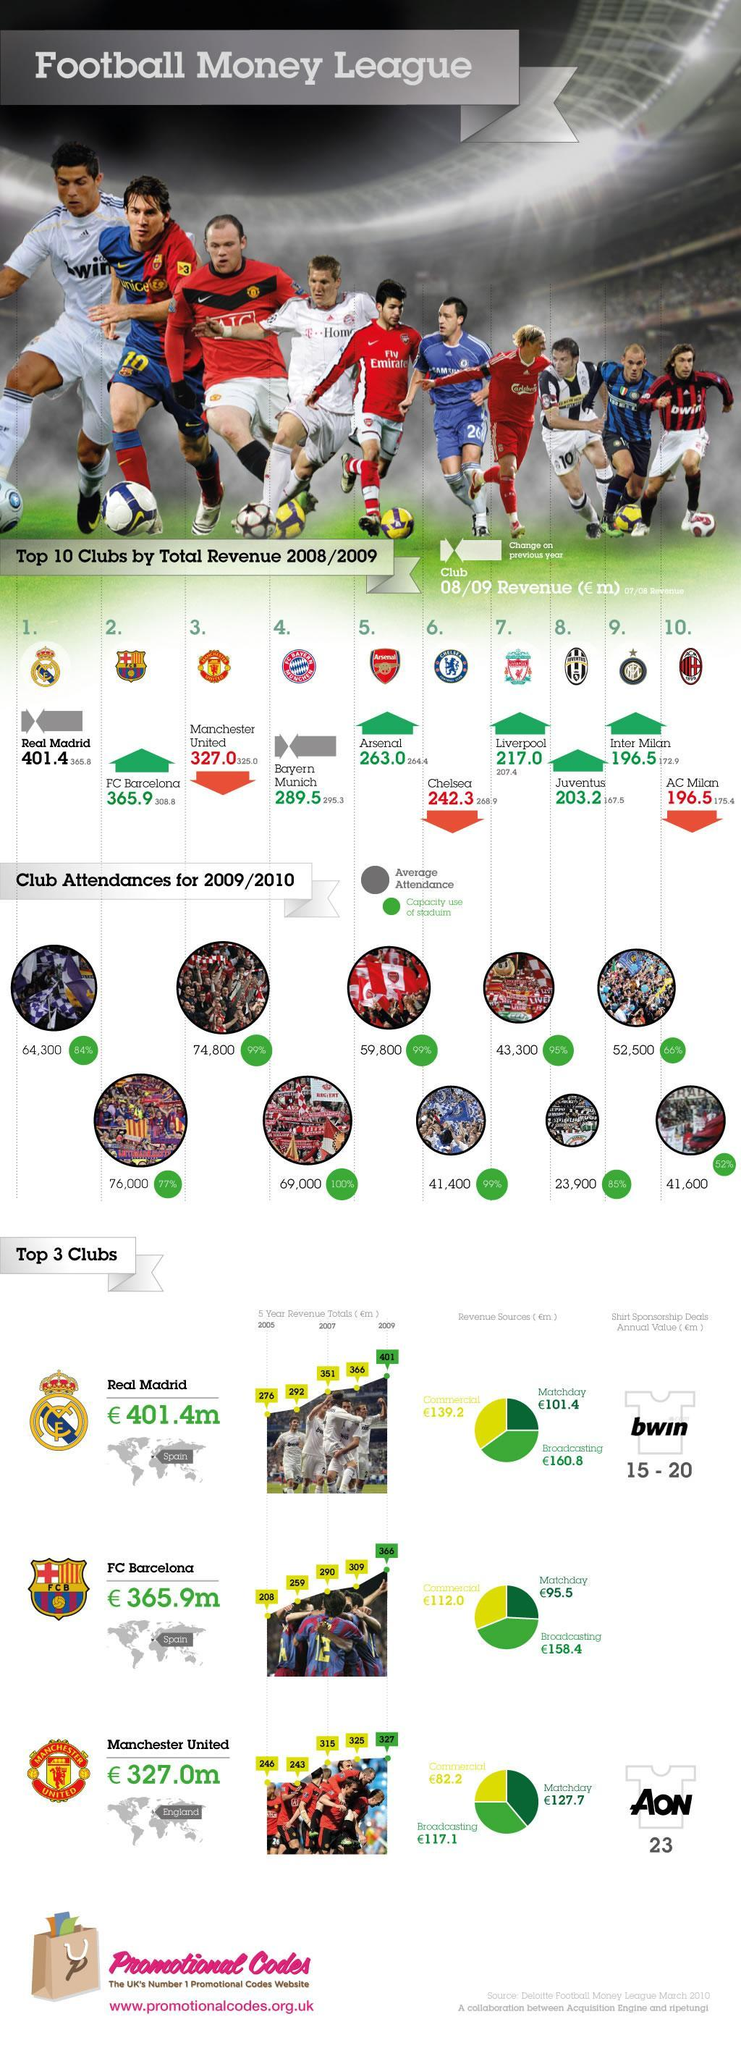What is the average attendance for the Liverpool F.C. games in 2009/2010?
Answer the question with a short phrase. 43,300 What is the percentage capacity use of stadium for Manchester United games in 2009/2010? 99% Which football club has generated the highest revenue in 2008/2009? Real Madrid What is the total revenue (in euro millions) generated by the Liverpool football club in 2008/2009? 217.0 What is the total revenue (in euro millions)  generated by the FC Barcelona in 2008? 309 What is the average attendance for the Arsenal F.C. games in 2009/2010? 59,800 What is the total revenue (in euro millions) generated by the Arsenal football club in 2007/2008? 264.4 What is the total revenue (in euro millions) generated by Chelsea football club in 2008/2009? 242.3 What is the percentage capacity use of stadium for Liverpool games in 2009/2010? 95% What is the total revenue (in euro millions) generated by the Manchester United in 2006? 243 